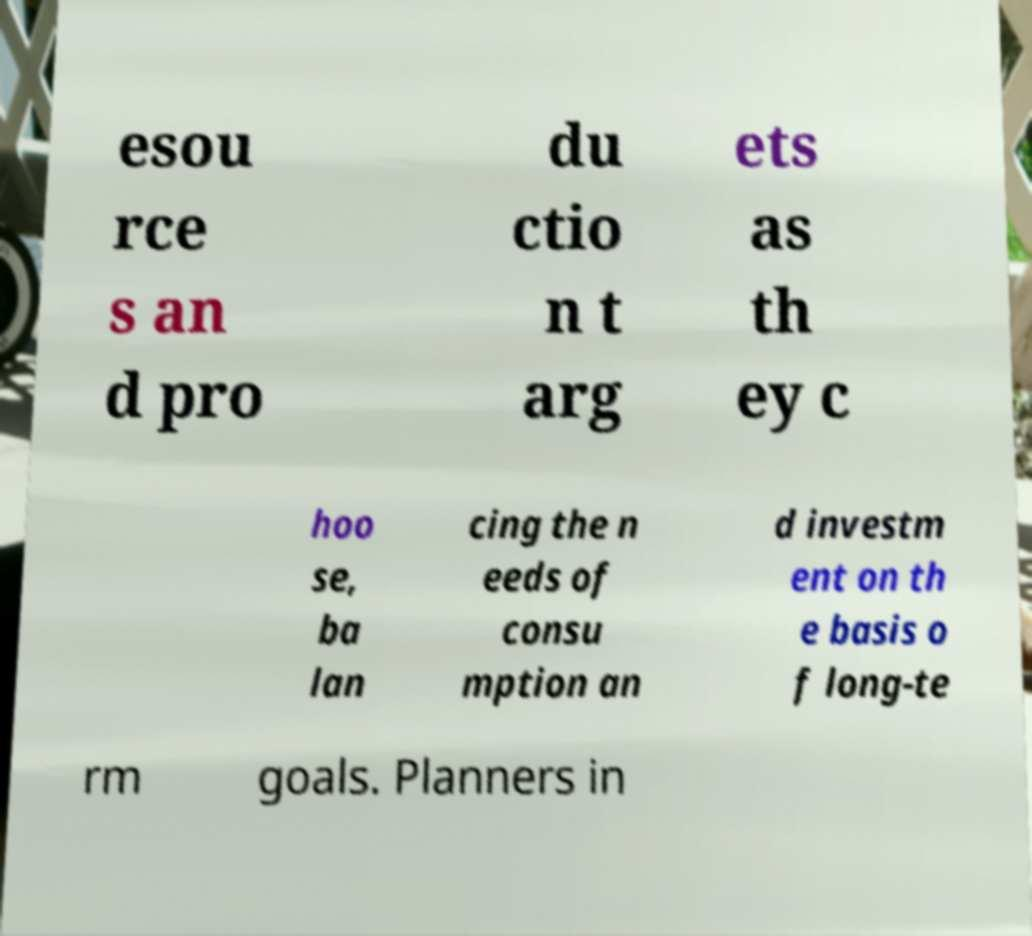Please read and relay the text visible in this image. What does it say? esou rce s an d pro du ctio n t arg ets as th ey c hoo se, ba lan cing the n eeds of consu mption an d investm ent on th e basis o f long-te rm goals. Planners in 